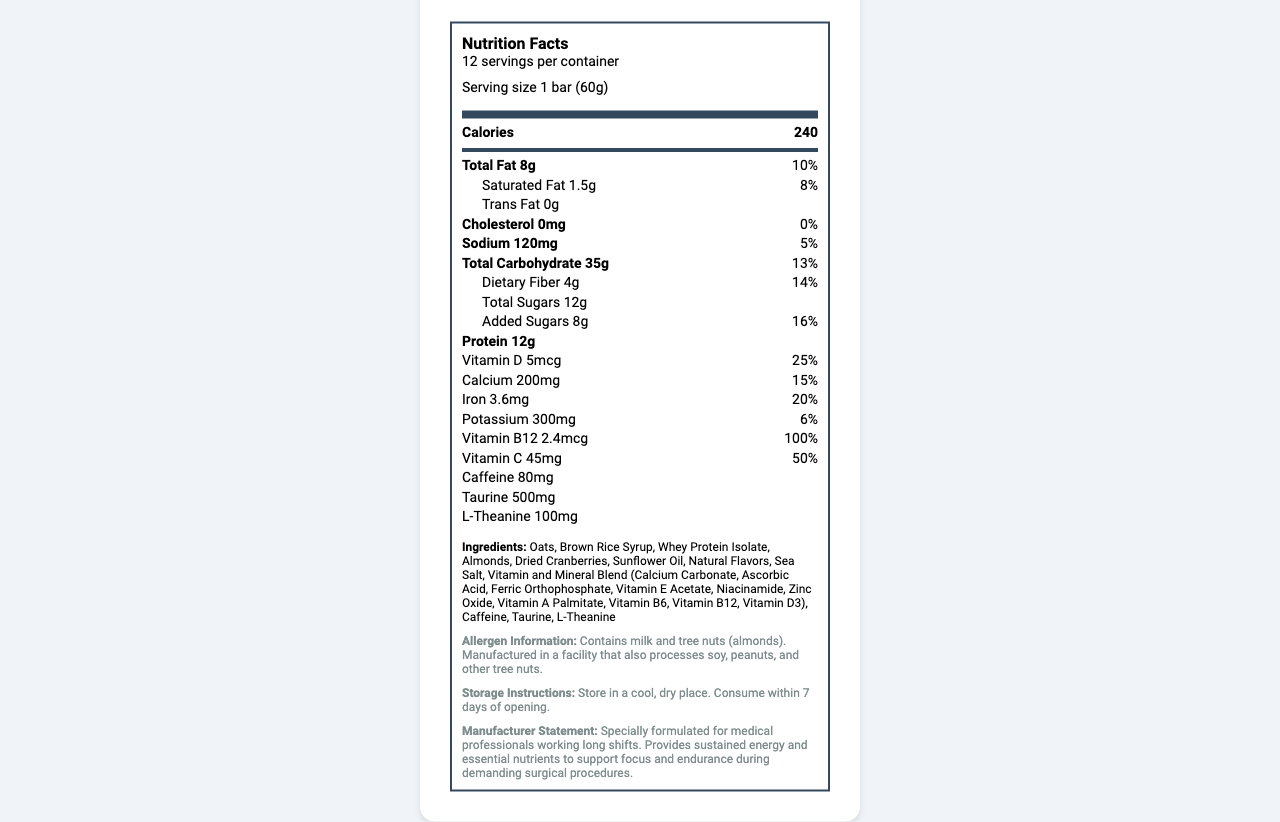what is the serving size of the SurgeonBoost Energy Bar? The serving size is specified as "1 bar (60g)" in the Nutrition Facts section.
Answer: 1 bar (60g) how many servings are there per container? The document states that there are "12 servings per container."
Answer: 12 what is the amount of total fat per serving? The Total Fat content per serving is listed as 8g.
Answer: 8g what percentage of the daily value for saturated fat does one bar contain? The Saturated Fat section shows that 1.5g constitutes 8% of the daily value.
Answer: 8% how much caffeine is in one serving of the energy bar? The document lists the caffeine content as 80mg per serving.
Answer: 80mg how many grams of dietary fiber are in one bar? The document indicates that there are 4g of dietary fiber per serving.
Answer: 4g how much added sugar does one bar contain? The Added Sugars section shows that one bar contains 8g of added sugars.
Answer: 8g what are the two main sources of protein in the SurgeonBoost Energy Bar? A. Oats and Almonds B. Whey Protein Isolate and Almonds C. Dried Cranberries and Oats D. Sunflower Oil and Sea Salt The ingredients list shows "Whey Protein Isolate" and "Almonds" as the two main sources contributing protein.
Answer: B which vitamin is present in the highest percentage of daily value per serving? A. Vitamin B12 B. Vitamin D C. Vitamin C D. Iron Vitamin B12 contributes 100% of the daily value per serving, the highest among the listed vitamins.
Answer: A do the energy bars contain any tree nuts? The allergen information section states that the bars contain tree nuts (almonds).
Answer: Yes describe the main idea of the document. The Nutrition Facts label presents an overview of the nutritional composition, including serving sizes, calories, macronutrients, vitamins, and minerals. It also lists additional ingredients and aspects such as caffeine content and allergen information meant for medical professionals.
Answer: The document provides the Nutrition Facts, ingredients, storage instructions, and manufacturer statement for the SurgeonBoost Energy Bar. The bar is specifically formulated for medical professionals working long shifts and contains essential nutrients like protein, vitamins, and minerals to support focus and endurance during demanding procedures. how many calories does one bar provide? The document lists 240 calories per serving.
Answer: 240 is the product suitable for people with soy allergies? The document notes that the product is manufactured in a facility that also processes soy, posing a possible risk of cross-contamination.
Answer: No what is the amount of potassium per serving? The potassium content per serving is 300mg.
Answer: 300mg are there any genetically modified organisms (GMOs) in the ingredients list? The document does not provide information regarding the presence or absence of GMOs.
Answer: Cannot be determined what storage condition is recommended for these energy bars? The storage instructions specify to store the bars in a cool, dry place and to consume them within 7 days of opening.
Answer: Store in a cool, dry place. Consume within 7 days of opening. 